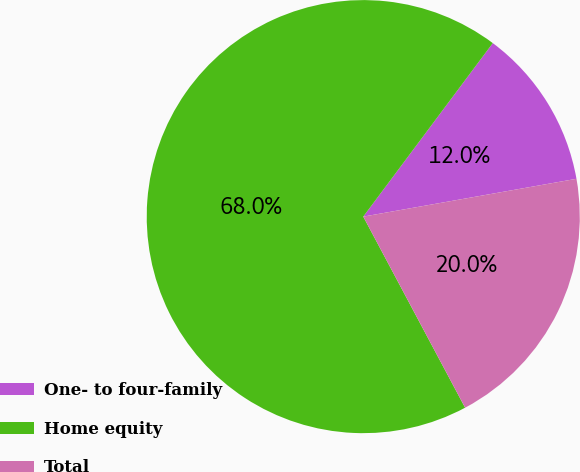<chart> <loc_0><loc_0><loc_500><loc_500><pie_chart><fcel>One- to four-family<fcel>Home equity<fcel>Total<nl><fcel>12.0%<fcel>68.0%<fcel>20.0%<nl></chart> 